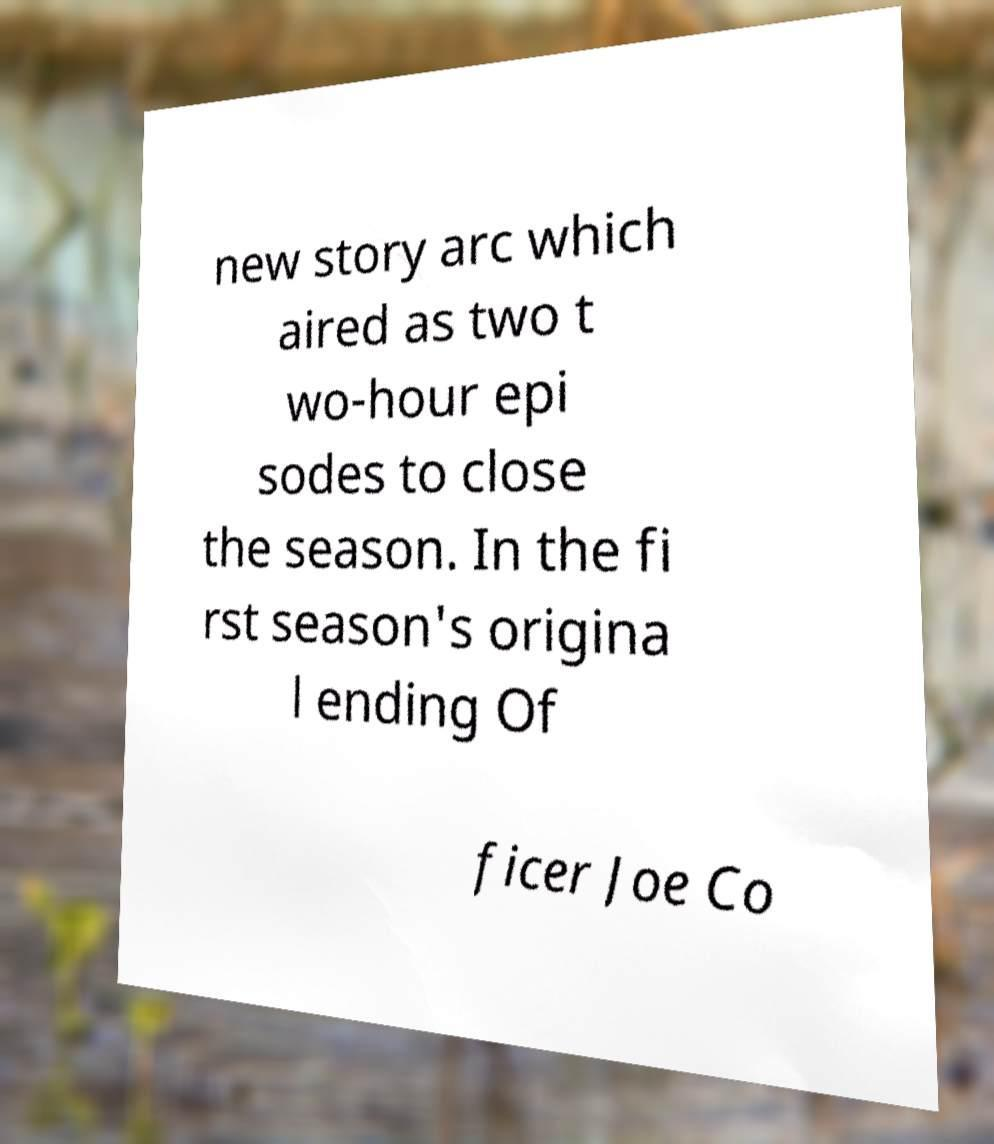Can you read and provide the text displayed in the image?This photo seems to have some interesting text. Can you extract and type it out for me? new story arc which aired as two t wo-hour epi sodes to close the season. In the fi rst season's origina l ending Of ficer Joe Co 